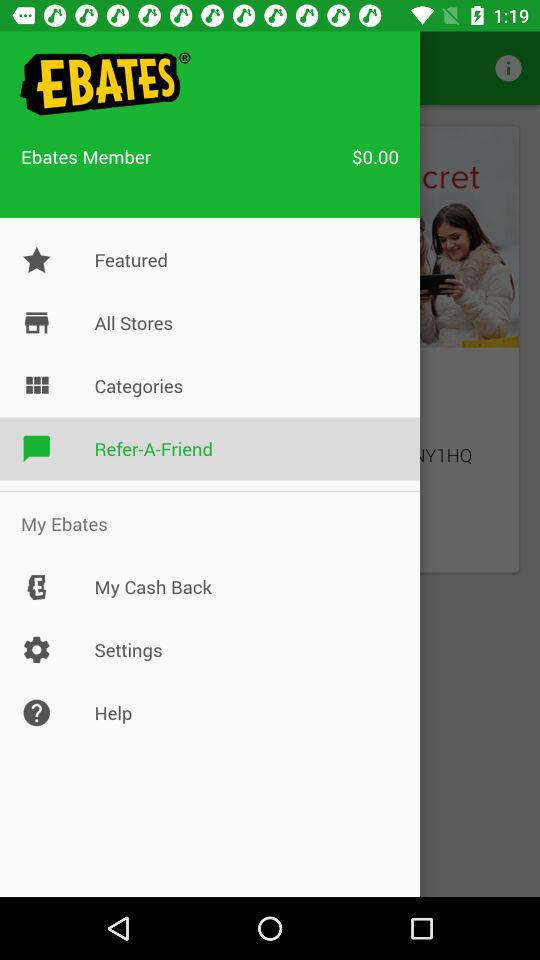How much is the total amount? The total amount is $0.00. 